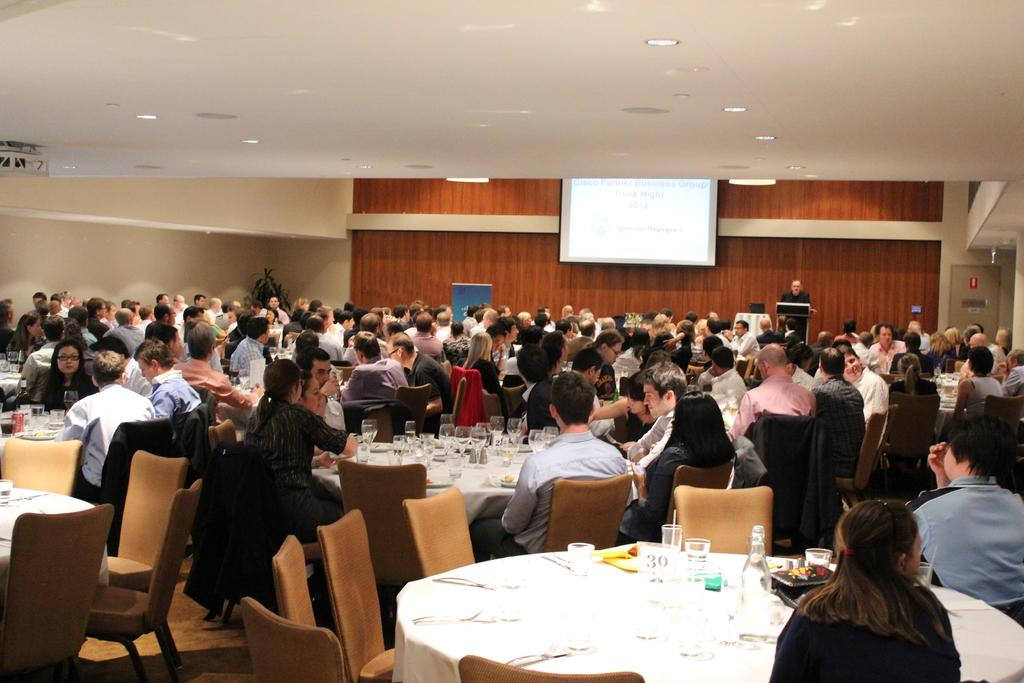What are the people in the image doing? The people in the image are sitting. What object can be seen in the image that is typically used for eating or drinking? There is a table in the image, which is commonly used for eating or drinking. What items are on the table in the image? Glasses are present on the table. Can you describe the person standing in the image? A person is standing at the back of the image. What is being displayed on the projector screen behind the standing person? A projector screen is being displayed behind the standing person. What type of snail can be seen crawling on the table in the image? There is no snail present in the image; it only features people sitting, a table, glasses, a standing person, and a projector screen. 